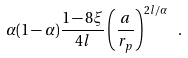<formula> <loc_0><loc_0><loc_500><loc_500>\alpha ( 1 - \alpha ) \frac { 1 - 8 \xi } { 4 l } \left ( \frac { a } { r _ { p } } \right ) ^ { 2 l / \alpha } \ .</formula> 